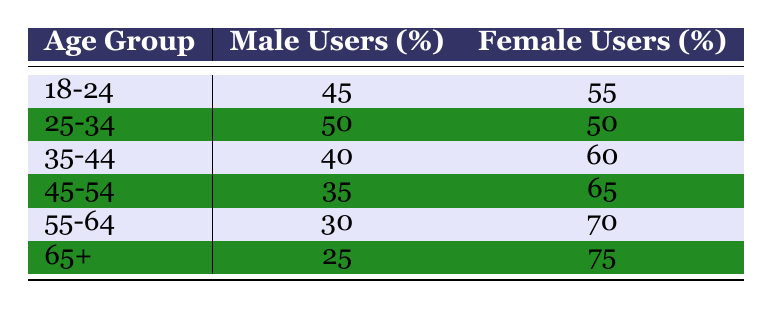What is the percentage of female users in the age group 35-44? According to the table, the age group 35-44 has 60 female users. This is directly stated in the table under the "Female Users" column for that age group.
Answer: 60 What is the total number of male users across all age groups? To find the total number of male users, we sum up the "Male Users" column: 45 + 50 + 40 + 35 + 30 + 25 = 225.
Answer: 225 Are there more female users than male users in the age group 45-54? For the age group 45-54, the table shows 35 male users and 65 female users. Since 65 is greater than 35, the statement is true.
Answer: Yes What is the difference in the number of users between males and females in the age group 55-64? The table indicates that there are 30 male users and 70 female users in the age group 55-64. The difference is calculated by subtracting the male users from female users: 70 - 30 = 40.
Answer: 40 What is the average percentage of male users across all age groups? To find the average percentage of male users, we first add all the percentages of male users: 45 + 50 + 40 + 35 + 30 + 25 = 225. Then, we divide by the number of age groups, which is 6: 225/6 = 37.5.
Answer: 37.5 Are there any age groups where the number of male users is greater than the number of female users? Looking at the table, for each group, it can be seen that males always have fewer users than females; the maximum male is 50 in the group 25-34, while females match this but do not fall below.
Answer: No In the age group 18-24, what is the ratio of male to female users? For age group 18-24, there are 45 male users and 55 female users. The ratio is 45 to 55, which can also be expressed in simplest form as 9:11.
Answer: 9:11 What percentage of users in the age group 65+ are male? The table shows there are 25 male users and 75 female users in the age group 65+. The total users in that group would be 25 + 75 = 100. The percentage of male users is then calculated as (25/100)*100 = 25%.
Answer: 25% 